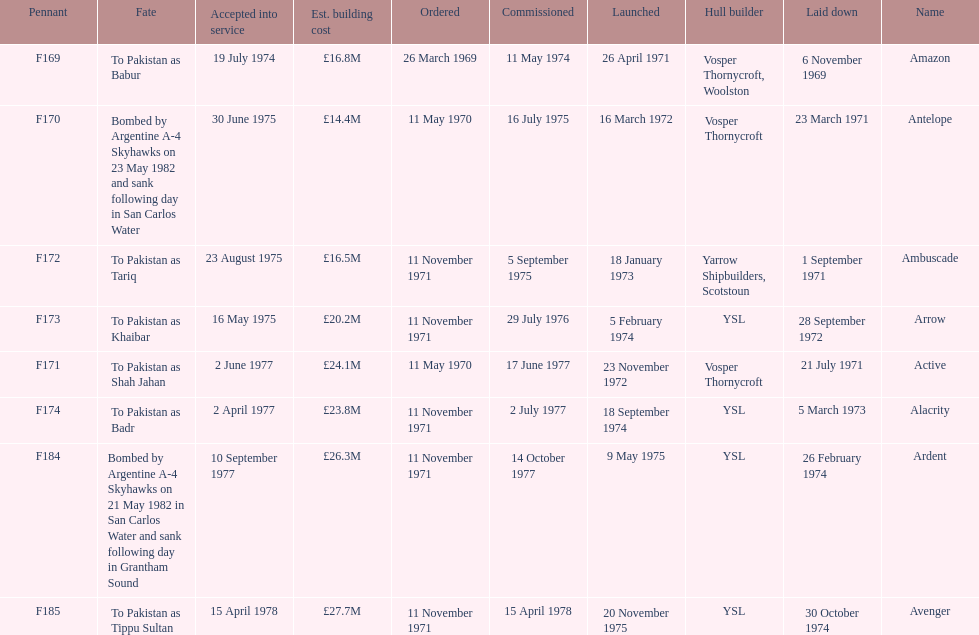What were the estimated building costs of the frigates? £16.8M, £14.4M, £16.5M, £20.2M, £24.1M, £23.8M, £26.3M, £27.7M. Which of these is the largest? £27.7M. What ship name does that correspond to? Avenger. 